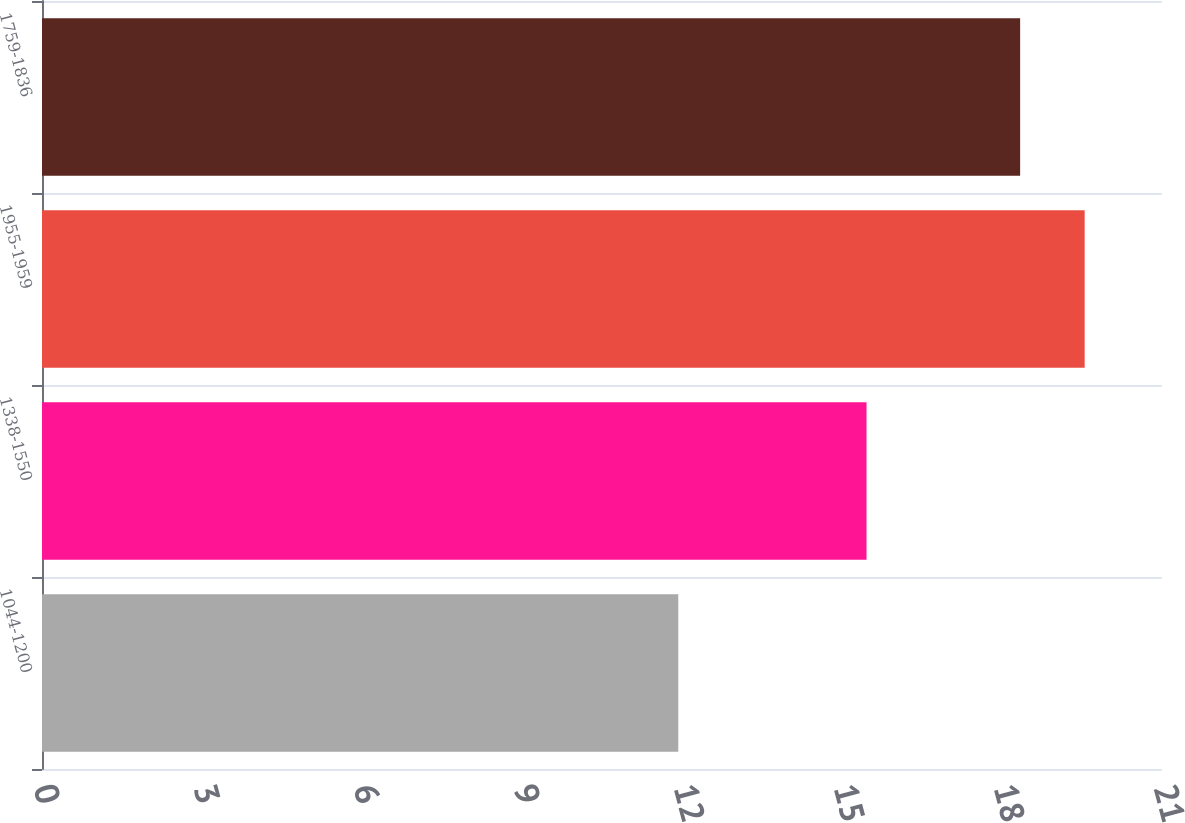Convert chart. <chart><loc_0><loc_0><loc_500><loc_500><bar_chart><fcel>1044-1200<fcel>1338-1550<fcel>1955-1959<fcel>1759-1836<nl><fcel>11.93<fcel>15.46<fcel>19.55<fcel>18.34<nl></chart> 